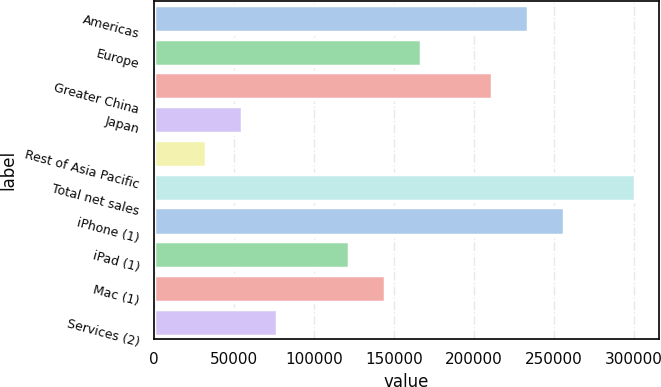Convert chart. <chart><loc_0><loc_0><loc_500><loc_500><bar_chart><fcel>Americas<fcel>Europe<fcel>Greater China<fcel>Japan<fcel>Rest of Asia Pacific<fcel>Total net sales<fcel>iPhone (1)<fcel>iPad (1)<fcel>Mac (1)<fcel>Services (2)<nl><fcel>233715<fcel>166621<fcel>211350<fcel>54796.6<fcel>32431.8<fcel>300809<fcel>256080<fcel>121891<fcel>144256<fcel>77161.4<nl></chart> 